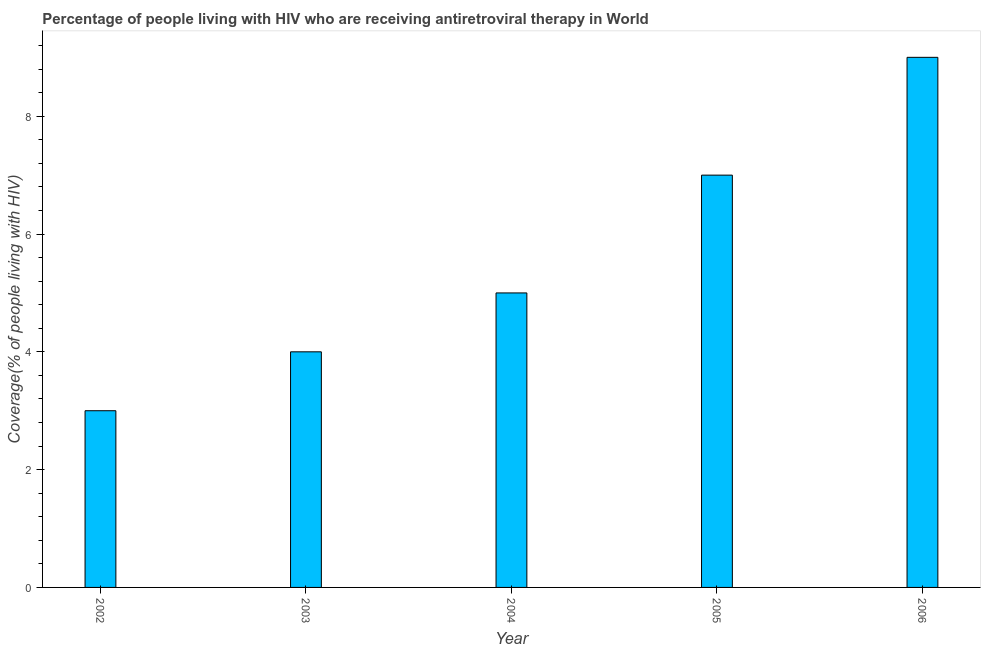Does the graph contain any zero values?
Your answer should be very brief. No. Does the graph contain grids?
Your response must be concise. No. What is the title of the graph?
Your answer should be very brief. Percentage of people living with HIV who are receiving antiretroviral therapy in World. What is the label or title of the X-axis?
Make the answer very short. Year. What is the label or title of the Y-axis?
Give a very brief answer. Coverage(% of people living with HIV). In which year was the antiretroviral therapy coverage maximum?
Keep it short and to the point. 2006. In which year was the antiretroviral therapy coverage minimum?
Ensure brevity in your answer.  2002. What is the sum of the antiretroviral therapy coverage?
Keep it short and to the point. 28. What is the difference between the antiretroviral therapy coverage in 2003 and 2004?
Provide a succinct answer. -1. What is the median antiretroviral therapy coverage?
Your answer should be very brief. 5. Is the difference between the antiretroviral therapy coverage in 2002 and 2003 greater than the difference between any two years?
Offer a terse response. No. What is the difference between the highest and the second highest antiretroviral therapy coverage?
Provide a short and direct response. 2. Is the sum of the antiretroviral therapy coverage in 2003 and 2005 greater than the maximum antiretroviral therapy coverage across all years?
Your response must be concise. Yes. How many bars are there?
Your response must be concise. 5. Are all the bars in the graph horizontal?
Offer a terse response. No. How many years are there in the graph?
Provide a succinct answer. 5. What is the difference between two consecutive major ticks on the Y-axis?
Give a very brief answer. 2. Are the values on the major ticks of Y-axis written in scientific E-notation?
Offer a very short reply. No. What is the Coverage(% of people living with HIV) in 2003?
Provide a succinct answer. 4. What is the difference between the Coverage(% of people living with HIV) in 2002 and 2003?
Make the answer very short. -1. What is the difference between the Coverage(% of people living with HIV) in 2002 and 2005?
Give a very brief answer. -4. What is the difference between the Coverage(% of people living with HIV) in 2002 and 2006?
Keep it short and to the point. -6. What is the difference between the Coverage(% of people living with HIV) in 2004 and 2005?
Offer a terse response. -2. What is the ratio of the Coverage(% of people living with HIV) in 2002 to that in 2003?
Your response must be concise. 0.75. What is the ratio of the Coverage(% of people living with HIV) in 2002 to that in 2005?
Your answer should be very brief. 0.43. What is the ratio of the Coverage(% of people living with HIV) in 2002 to that in 2006?
Provide a succinct answer. 0.33. What is the ratio of the Coverage(% of people living with HIV) in 2003 to that in 2005?
Provide a succinct answer. 0.57. What is the ratio of the Coverage(% of people living with HIV) in 2003 to that in 2006?
Your response must be concise. 0.44. What is the ratio of the Coverage(% of people living with HIV) in 2004 to that in 2005?
Provide a succinct answer. 0.71. What is the ratio of the Coverage(% of people living with HIV) in 2004 to that in 2006?
Give a very brief answer. 0.56. What is the ratio of the Coverage(% of people living with HIV) in 2005 to that in 2006?
Keep it short and to the point. 0.78. 